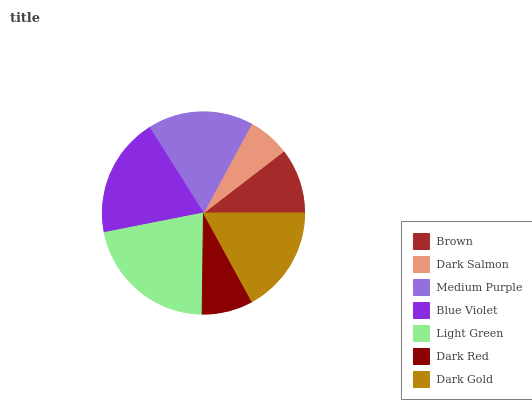Is Dark Salmon the minimum?
Answer yes or no. Yes. Is Light Green the maximum?
Answer yes or no. Yes. Is Medium Purple the minimum?
Answer yes or no. No. Is Medium Purple the maximum?
Answer yes or no. No. Is Medium Purple greater than Dark Salmon?
Answer yes or no. Yes. Is Dark Salmon less than Medium Purple?
Answer yes or no. Yes. Is Dark Salmon greater than Medium Purple?
Answer yes or no. No. Is Medium Purple less than Dark Salmon?
Answer yes or no. No. Is Medium Purple the high median?
Answer yes or no. Yes. Is Medium Purple the low median?
Answer yes or no. Yes. Is Dark Red the high median?
Answer yes or no. No. Is Dark Red the low median?
Answer yes or no. No. 